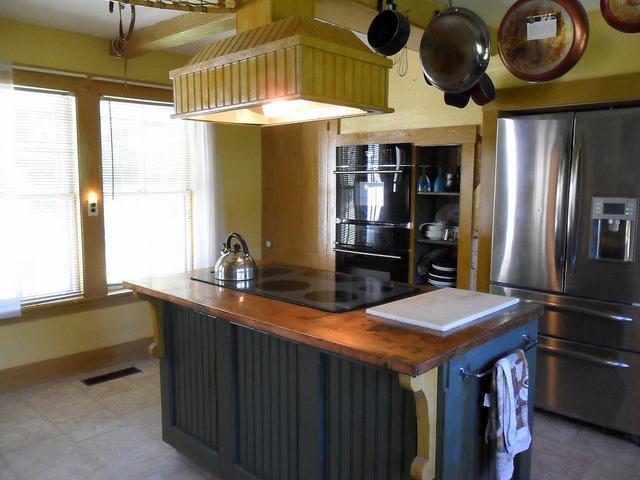What is the white rectangle on the island for?
Answer the question by selecting the correct answer among the 4 following choices.
Options: Cutting, decoration, mixing, warming. Cutting. 